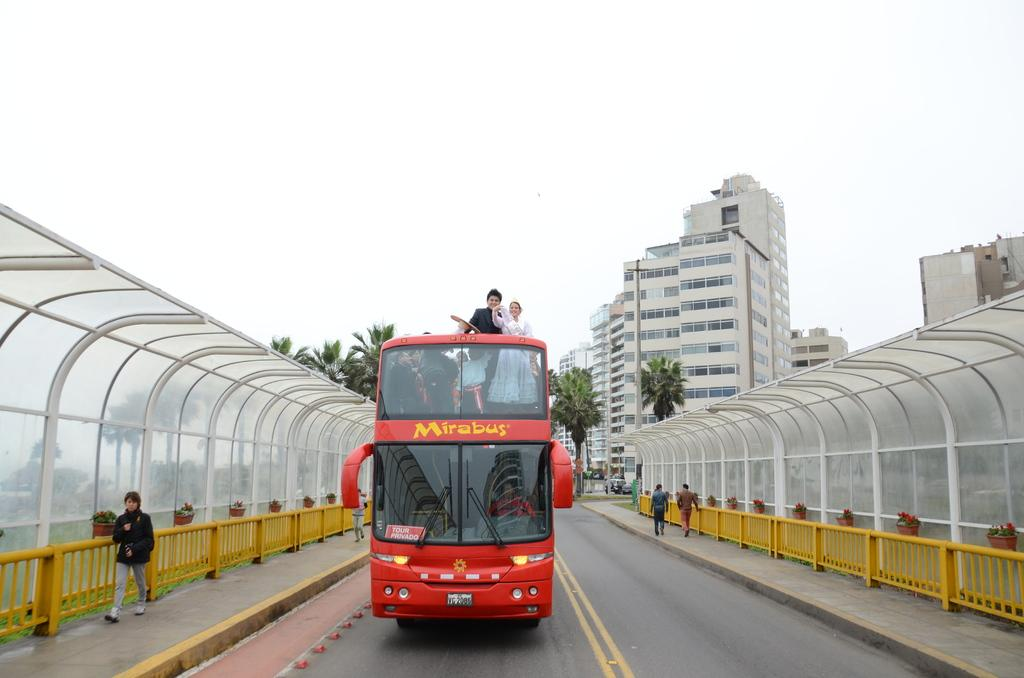<image>
Offer a succinct explanation of the picture presented. A couple stands together on the top level of a Mirabus. 